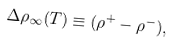Convert formula to latex. <formula><loc_0><loc_0><loc_500><loc_500>\Delta \rho _ { \infty } ( T ) \equiv ( \rho ^ { + } - \rho ^ { - } ) ,</formula> 